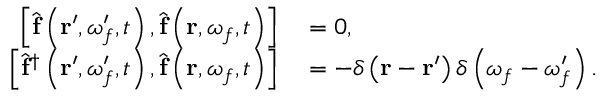Convert formula to latex. <formula><loc_0><loc_0><loc_500><loc_500>\begin{array} { r l } { \left [ \hat { f } \left ( r ^ { \prime } , \omega _ { f } ^ { \prime } , t \right ) , \hat { f } \left ( r , \omega _ { f } , t \right ) \right ] } & = 0 , } \\ { \left [ \hat { f } ^ { \dagger } \left ( r ^ { \prime } , \omega _ { f } ^ { \prime } , t \right ) , \hat { f } \left ( r , \omega _ { f } , t \right ) \right ] } & = - \delta \left ( r - r ^ { \prime } \right ) \delta \left ( \omega _ { f } - \omega _ { f } ^ { \prime } \right ) . } \end{array}</formula> 